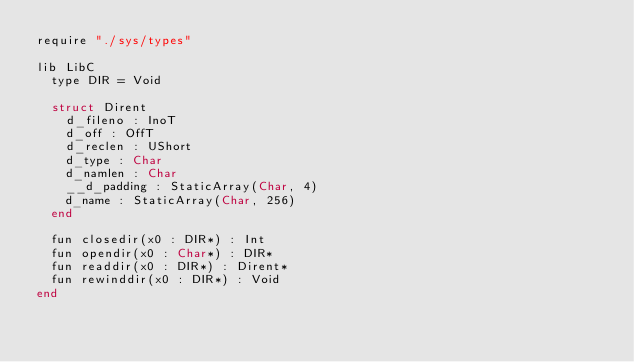Convert code to text. <code><loc_0><loc_0><loc_500><loc_500><_Crystal_>require "./sys/types"

lib LibC
  type DIR = Void

  struct Dirent
    d_fileno : InoT
    d_off : OffT
    d_reclen : UShort
    d_type : Char
    d_namlen : Char
    __d_padding : StaticArray(Char, 4)
    d_name : StaticArray(Char, 256)
  end

  fun closedir(x0 : DIR*) : Int
  fun opendir(x0 : Char*) : DIR*
  fun readdir(x0 : DIR*) : Dirent*
  fun rewinddir(x0 : DIR*) : Void
end
</code> 